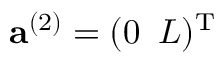<formula> <loc_0><loc_0><loc_500><loc_500>{ a } ^ { ( 2 ) } = ( 0 \, L ) ^ { T }</formula> 